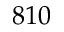Convert formula to latex. <formula><loc_0><loc_0><loc_500><loc_500>8 1 0</formula> 